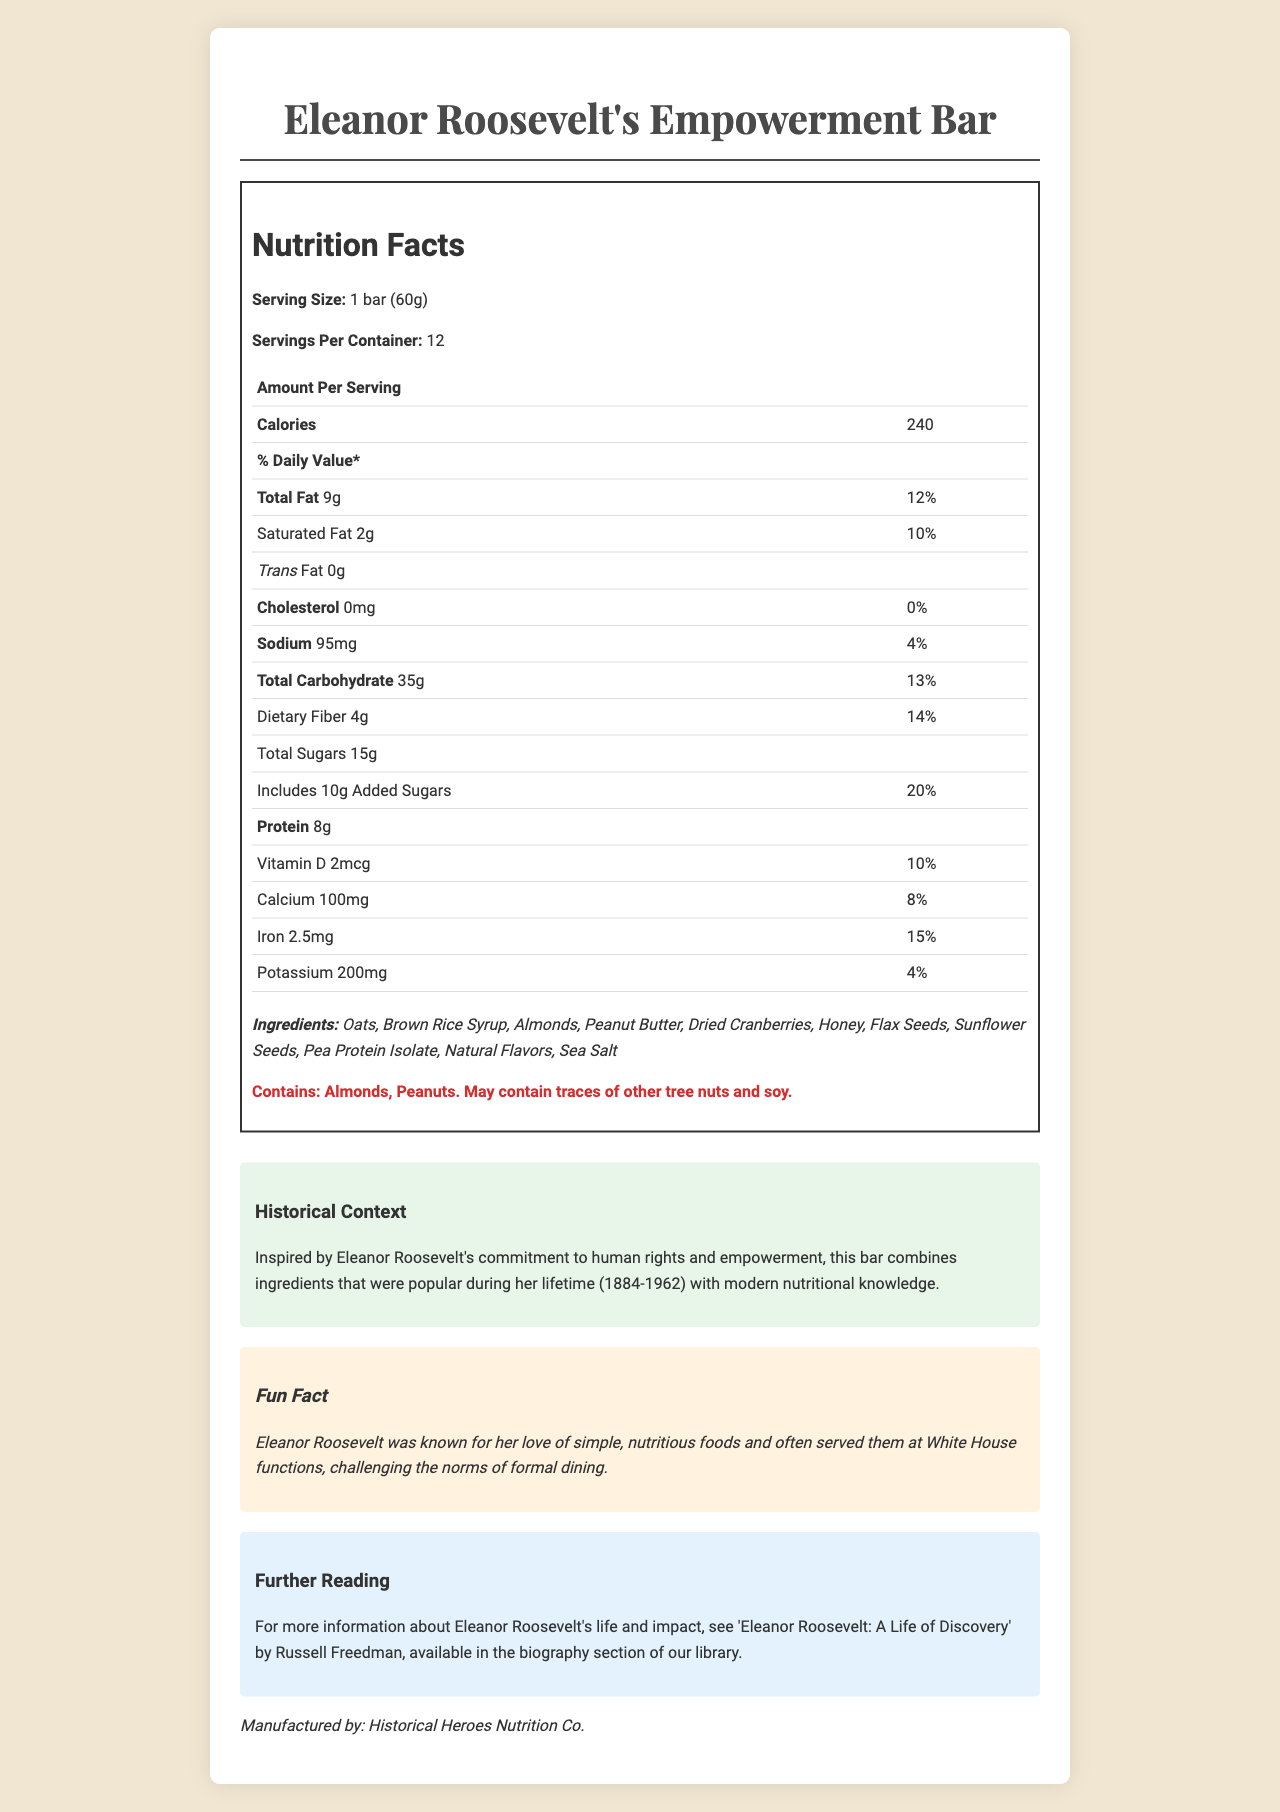what is the serving size of the energy bar? The serving size is explicitly mentioned as "1 bar (60g)" in the nutrition facts.
Answer: 1 bar (60g) how many calories are in one serving of Eleanor Roosevelt's Empowerment Bar? The calories per serving are listed as 240 in the nutrition facts.
Answer: 240 what is the total fat content per serving? The total fat content per serving is mentioned as 9g.
Answer: 9g how much protein does one bar contain? The protein content per serving is listed as 8g.
Answer: 8g what are the added sugars content and its percentage of daily value? The added sugars content is 10g, and its daily value percentage is 20%.
Answer: 10g, 20% how many servings are in the entire container? A. 6 B. 12 C. 20 The document states that there are 12 servings per container.
Answer: B what is the amount of iron present per serving? A. 1.5mg B. 2.5mg C. 4.5mg D. 5.5mg Each serving has 2.5mg of iron.
Answer: B does the bar contain any trans fat? The trans fat content is listed as 0g.
Answer: No is the bar suitable for someone with a peanut allergy? The allergen information indicates that the bar contains peanuts.
Answer: No summarize the main idea of Eleanor Roosevelt's Empowerment Bar nutrition label. The document offers a comprehensive overview of the nutritional content and background of the energy bar, designed to reflect Eleanor Roosevelt's values and dietary preferences, along with practical information like ingredients and allergen warnings.
Answer: The document details the nutrition facts of Eleanor Roosevelt's Empowerment Bar, including serving size, calories, and nutrient content. It highlights the ingredients, allergens, and provides historical context related to Eleanor Roosevelt. how many calories from fat are in one serving? The document lists total fat but does not separately specify calories from fat.
Answer: Not enough information 